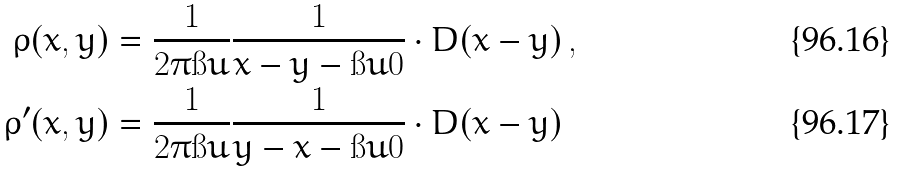Convert formula to latex. <formula><loc_0><loc_0><loc_500><loc_500>\rho ( x , y ) & = \frac { 1 } { 2 \pi \i u } \frac { 1 } { x - y - \i u 0 } \cdot D ( x - y ) \, , \\ \rho ^ { \prime } ( x , y ) & = \frac { 1 } { 2 \pi \i u } \frac { 1 } { y - x - \i u 0 } \cdot D ( x - y )</formula> 